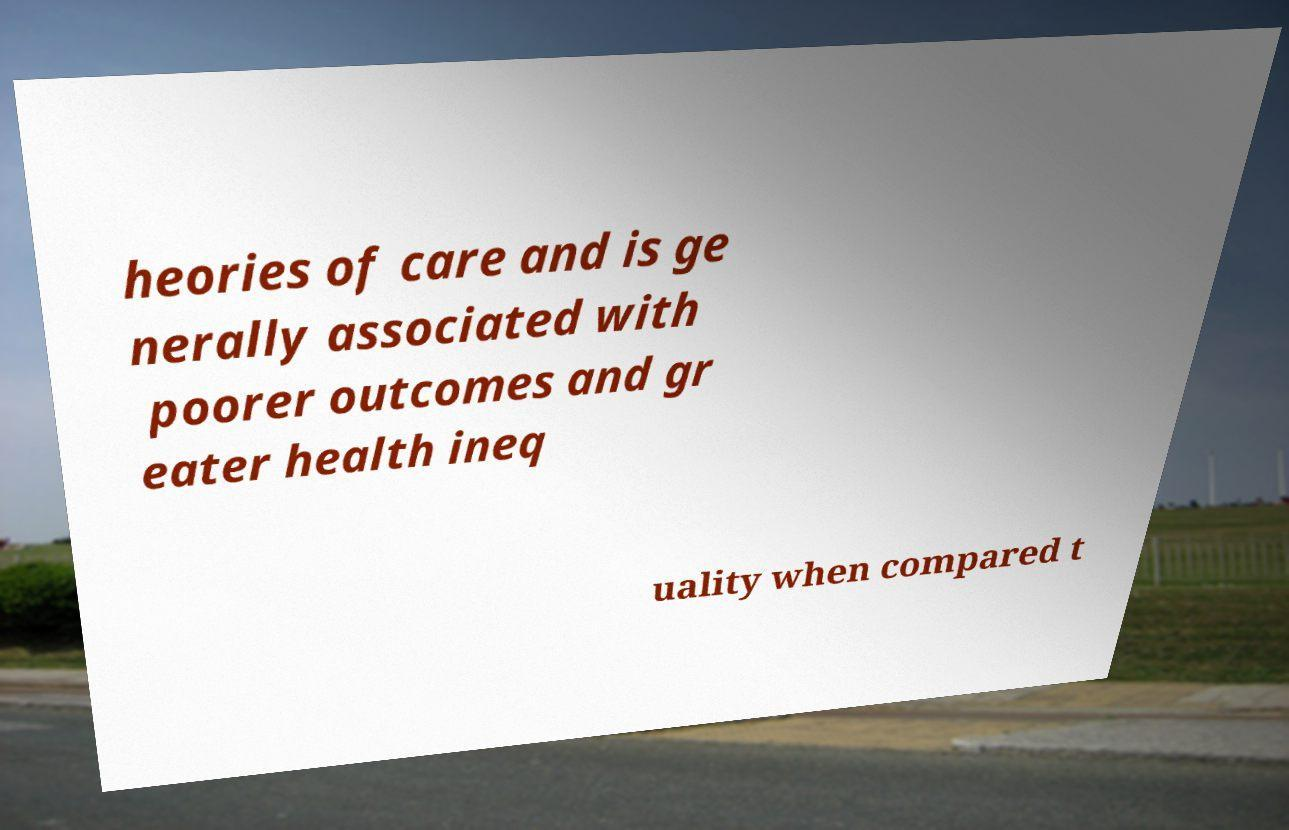I need the written content from this picture converted into text. Can you do that? heories of care and is ge nerally associated with poorer outcomes and gr eater health ineq uality when compared t 